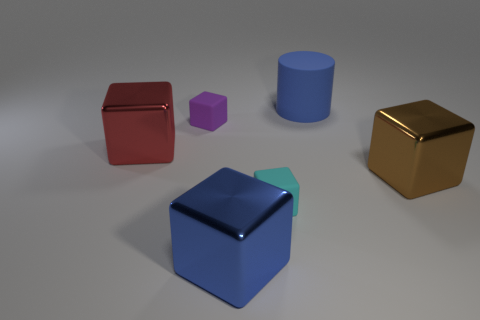Subtract all big blue blocks. How many blocks are left? 4 Subtract 2 blocks. How many blocks are left? 3 Subtract all red cubes. How many cubes are left? 4 Subtract all red blocks. Subtract all cyan balls. How many blocks are left? 4 Add 4 tiny red metal cubes. How many objects exist? 10 Subtract all blocks. How many objects are left? 1 Subtract 0 gray spheres. How many objects are left? 6 Subtract all large shiny things. Subtract all blue matte objects. How many objects are left? 2 Add 2 red metal things. How many red metal things are left? 3 Add 1 cyan balls. How many cyan balls exist? 1 